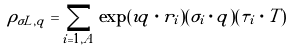<formula> <loc_0><loc_0><loc_500><loc_500>\rho _ { \sigma L , q } = \sum _ { i = 1 , A } \exp ( \imath { q } \cdot { r } _ { i } ) ( { \sigma } _ { i } \cdot { q } ) ( { \tau } _ { i } \cdot { T } )</formula> 